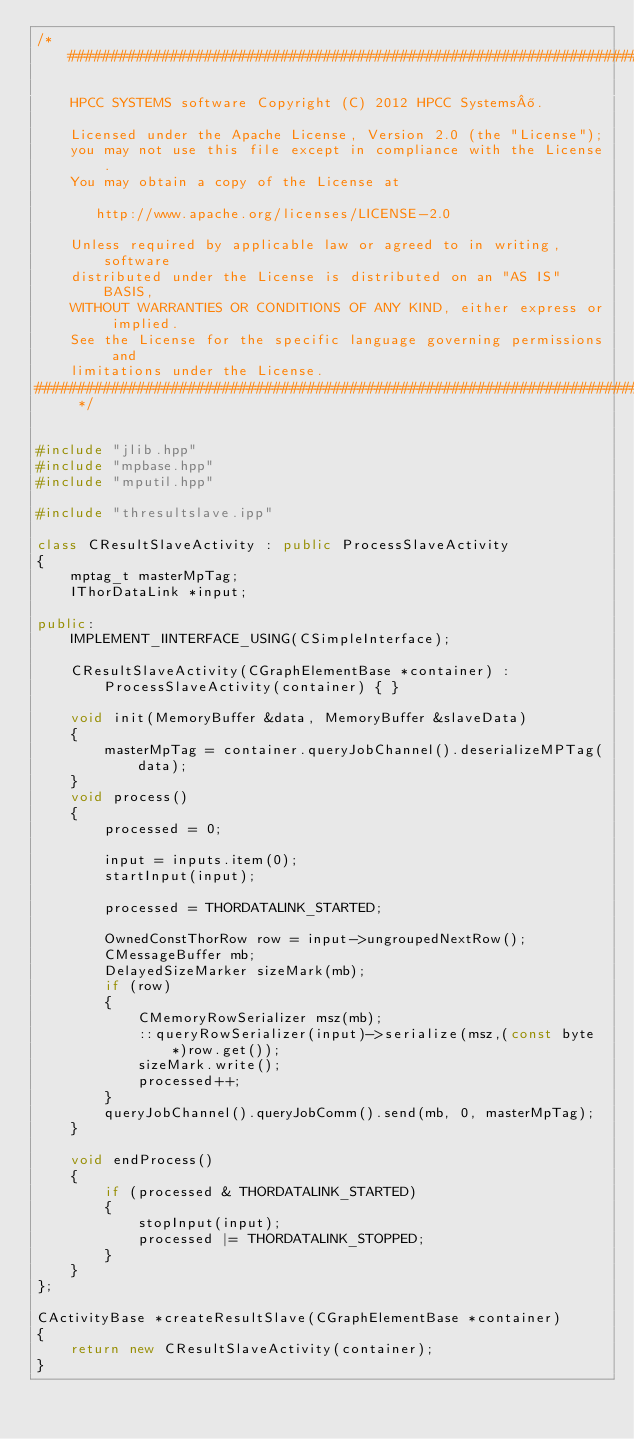Convert code to text. <code><loc_0><loc_0><loc_500><loc_500><_C++_>/*##############################################################################

    HPCC SYSTEMS software Copyright (C) 2012 HPCC Systems®.

    Licensed under the Apache License, Version 2.0 (the "License");
    you may not use this file except in compliance with the License.
    You may obtain a copy of the License at

       http://www.apache.org/licenses/LICENSE-2.0

    Unless required by applicable law or agreed to in writing, software
    distributed under the License is distributed on an "AS IS" BASIS,
    WITHOUT WARRANTIES OR CONDITIONS OF ANY KIND, either express or implied.
    See the License for the specific language governing permissions and
    limitations under the License.
############################################################################## */


#include "jlib.hpp"
#include "mpbase.hpp"
#include "mputil.hpp"

#include "thresultslave.ipp"

class CResultSlaveActivity : public ProcessSlaveActivity
{
    mptag_t masterMpTag;
    IThorDataLink *input;

public:
    IMPLEMENT_IINTERFACE_USING(CSimpleInterface);

    CResultSlaveActivity(CGraphElementBase *container) : ProcessSlaveActivity(container) { }

    void init(MemoryBuffer &data, MemoryBuffer &slaveData)
    {
        masterMpTag = container.queryJobChannel().deserializeMPTag(data);
    }
    void process()
    {
        processed = 0;

        input = inputs.item(0);
        startInput(input);

        processed = THORDATALINK_STARTED;

        OwnedConstThorRow row = input->ungroupedNextRow();
        CMessageBuffer mb;
        DelayedSizeMarker sizeMark(mb);
        if (row)
        {
            CMemoryRowSerializer msz(mb);
            ::queryRowSerializer(input)->serialize(msz,(const byte *)row.get());
            sizeMark.write();
            processed++;
        }
        queryJobChannel().queryJobComm().send(mb, 0, masterMpTag);
    }

    void endProcess()
    {
        if (processed & THORDATALINK_STARTED)
        {
            stopInput(input);
            processed |= THORDATALINK_STOPPED;
        }
    }
};

CActivityBase *createResultSlave(CGraphElementBase *container)
{
    return new CResultSlaveActivity(container);
}

</code> 